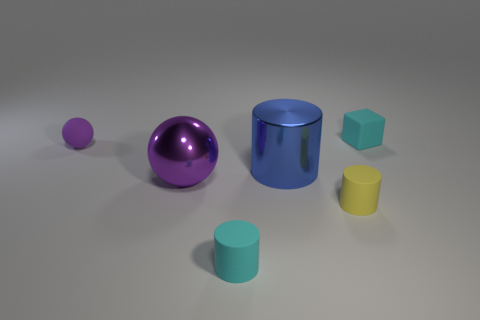Subtract all rubber cylinders. How many cylinders are left? 1 Add 4 tiny matte cylinders. How many objects exist? 10 Subtract 1 cubes. How many cubes are left? 0 Subtract all yellow cylinders. How many cylinders are left? 2 Subtract all blocks. How many objects are left? 5 Add 3 large objects. How many large objects are left? 5 Add 6 yellow matte things. How many yellow matte things exist? 7 Subtract 0 yellow blocks. How many objects are left? 6 Subtract all yellow cylinders. Subtract all blue blocks. How many cylinders are left? 2 Subtract all big purple spheres. Subtract all big blue metal things. How many objects are left? 4 